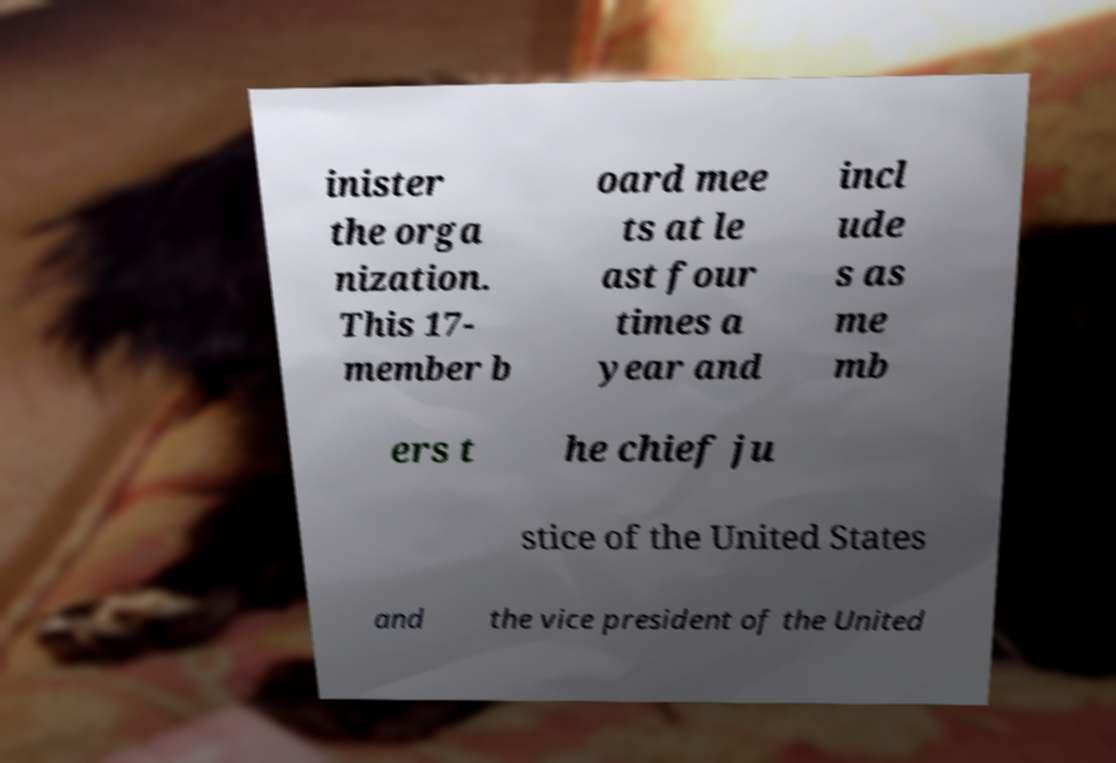Could you assist in decoding the text presented in this image and type it out clearly? inister the orga nization. This 17- member b oard mee ts at le ast four times a year and incl ude s as me mb ers t he chief ju stice of the United States and the vice president of the United 